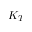Convert formula to latex. <formula><loc_0><loc_0><loc_500><loc_500>K _ { T }</formula> 